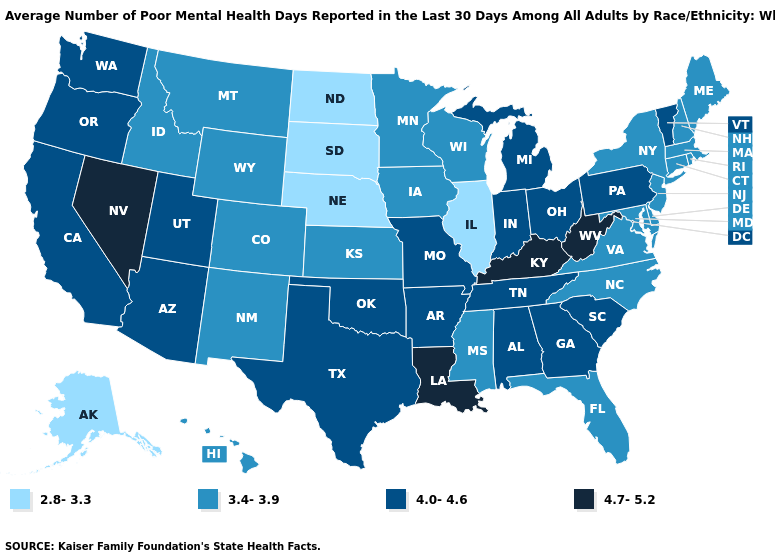What is the lowest value in states that border Ohio?
Write a very short answer. 4.0-4.6. What is the value of Arkansas?
Concise answer only. 4.0-4.6. Does South Carolina have a higher value than Alabama?
Answer briefly. No. Is the legend a continuous bar?
Quick response, please. No. What is the value of West Virginia?
Quick response, please. 4.7-5.2. What is the value of Texas?
Be succinct. 4.0-4.6. Name the states that have a value in the range 4.0-4.6?
Write a very short answer. Alabama, Arizona, Arkansas, California, Georgia, Indiana, Michigan, Missouri, Ohio, Oklahoma, Oregon, Pennsylvania, South Carolina, Tennessee, Texas, Utah, Vermont, Washington. Which states hav the highest value in the Northeast?
Quick response, please. Pennsylvania, Vermont. Name the states that have a value in the range 4.0-4.6?
Short answer required. Alabama, Arizona, Arkansas, California, Georgia, Indiana, Michigan, Missouri, Ohio, Oklahoma, Oregon, Pennsylvania, South Carolina, Tennessee, Texas, Utah, Vermont, Washington. Which states have the lowest value in the USA?
Concise answer only. Alaska, Illinois, Nebraska, North Dakota, South Dakota. Does Alaska have the lowest value in the USA?
Keep it brief. Yes. What is the highest value in the West ?
Keep it brief. 4.7-5.2. Name the states that have a value in the range 4.0-4.6?
Concise answer only. Alabama, Arizona, Arkansas, California, Georgia, Indiana, Michigan, Missouri, Ohio, Oklahoma, Oregon, Pennsylvania, South Carolina, Tennessee, Texas, Utah, Vermont, Washington. What is the lowest value in the MidWest?
Keep it brief. 2.8-3.3. What is the value of Delaware?
Quick response, please. 3.4-3.9. 